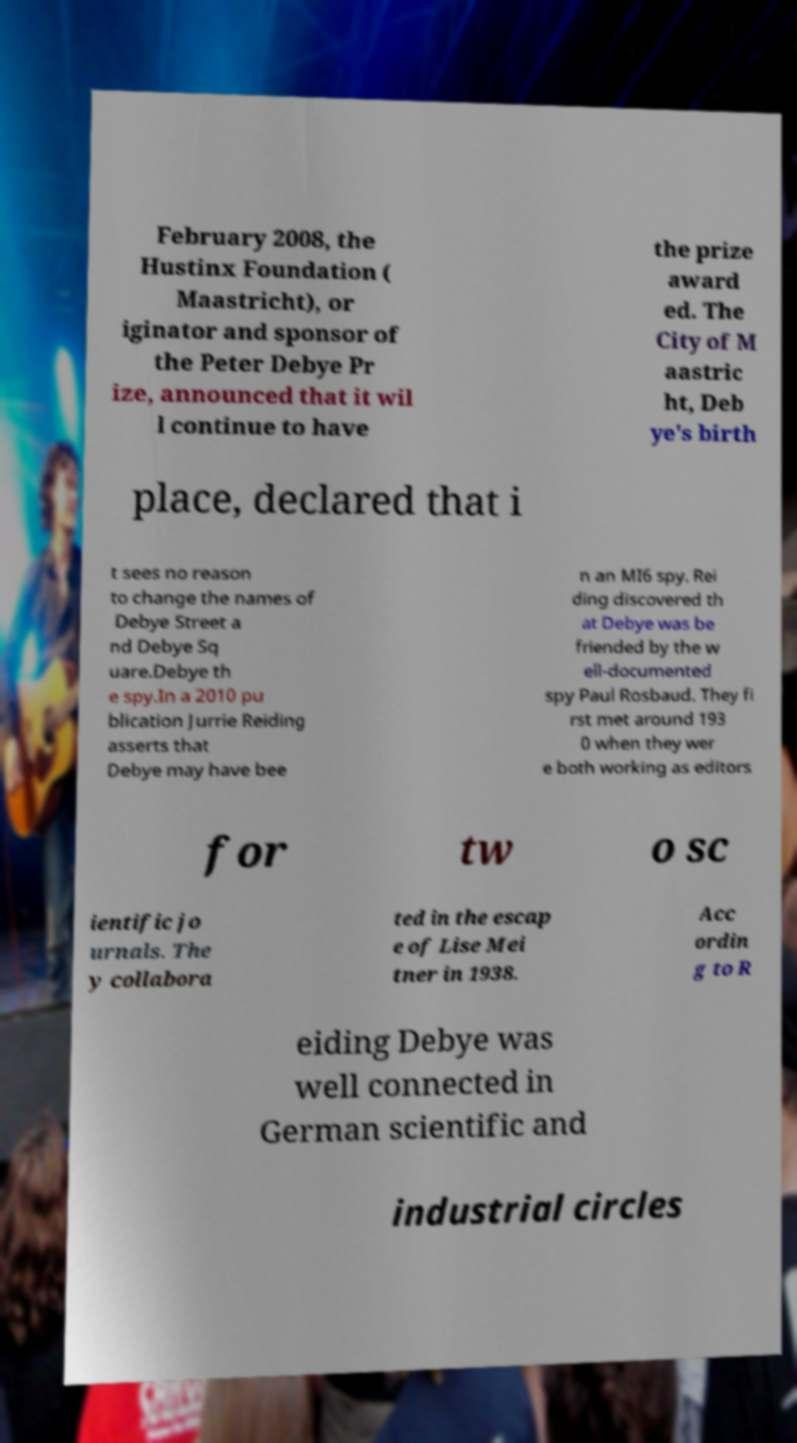Can you read and provide the text displayed in the image?This photo seems to have some interesting text. Can you extract and type it out for me? February 2008, the Hustinx Foundation ( Maastricht), or iginator and sponsor of the Peter Debye Pr ize, announced that it wil l continue to have the prize award ed. The City of M aastric ht, Deb ye's birth place, declared that i t sees no reason to change the names of Debye Street a nd Debye Sq uare.Debye th e spy.In a 2010 pu blication Jurrie Reiding asserts that Debye may have bee n an MI6 spy. Rei ding discovered th at Debye was be friended by the w ell-documented spy Paul Rosbaud. They fi rst met around 193 0 when they wer e both working as editors for tw o sc ientific jo urnals. The y collabora ted in the escap e of Lise Mei tner in 1938. Acc ordin g to R eiding Debye was well connected in German scientific and industrial circles 